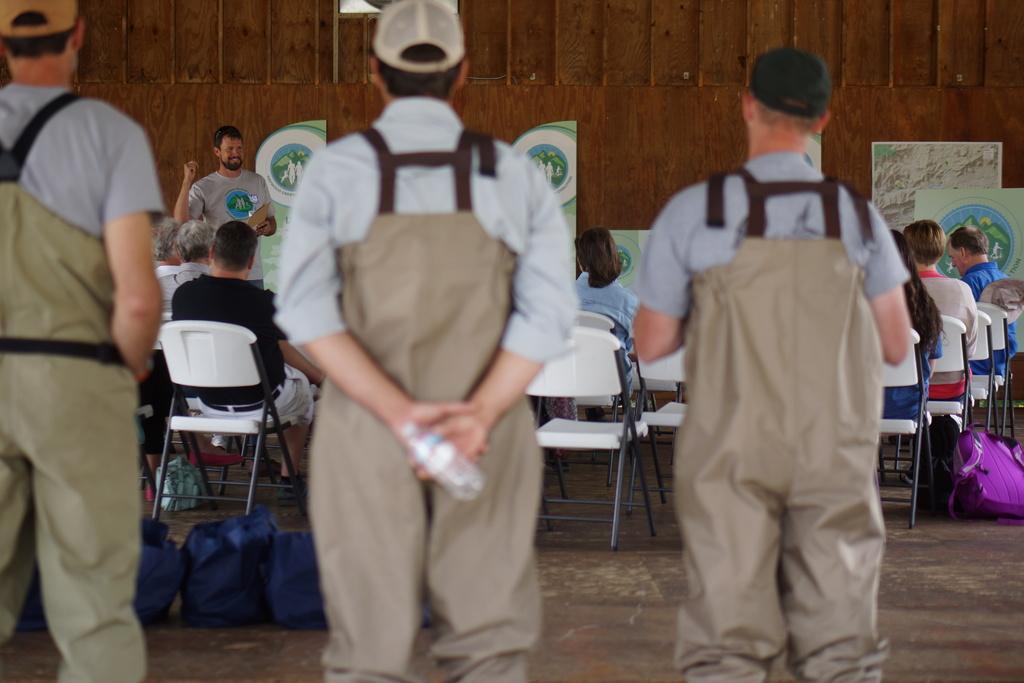In one or two sentences, can you explain what this image depicts? In this image we can see a few people, among them some are sitting on the chairs and some are standing, there are some posters with images and text, also we can see some bags, water bottles and the wall. 